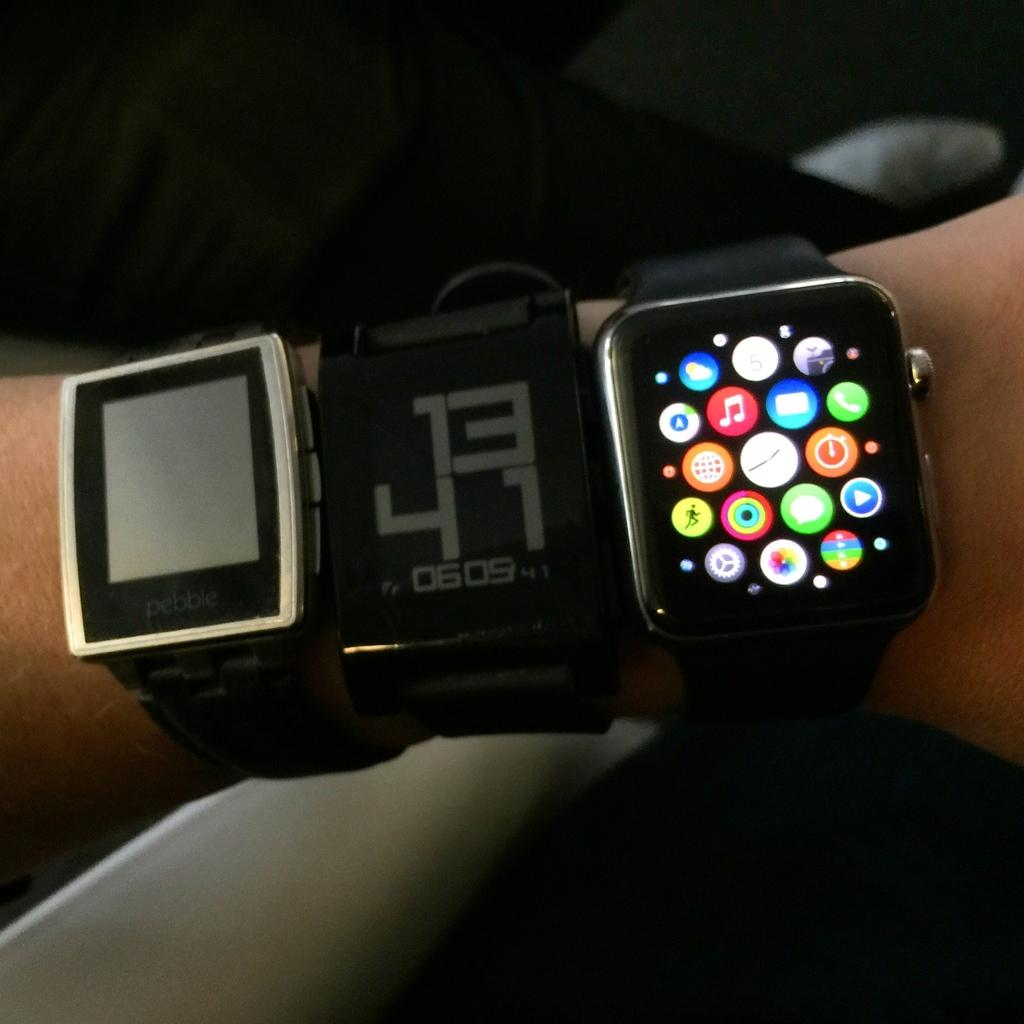<image>
Summarize the visual content of the image. Person wearing three watches including one that says 1341. 